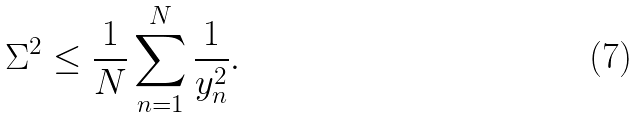Convert formula to latex. <formula><loc_0><loc_0><loc_500><loc_500>\Sigma ^ { 2 } \leq \frac { 1 } { N } \sum _ { n = 1 } ^ { N } \frac { 1 } { y _ { n } ^ { 2 } } .</formula> 